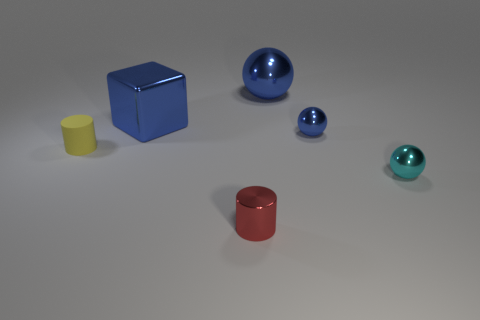Is the color of the cube the same as the large metal sphere? Yes, the color of the cube and the large metal sphere both exhibit a similar shade of blue, giving the objects a cohesive appearance within this setting. 